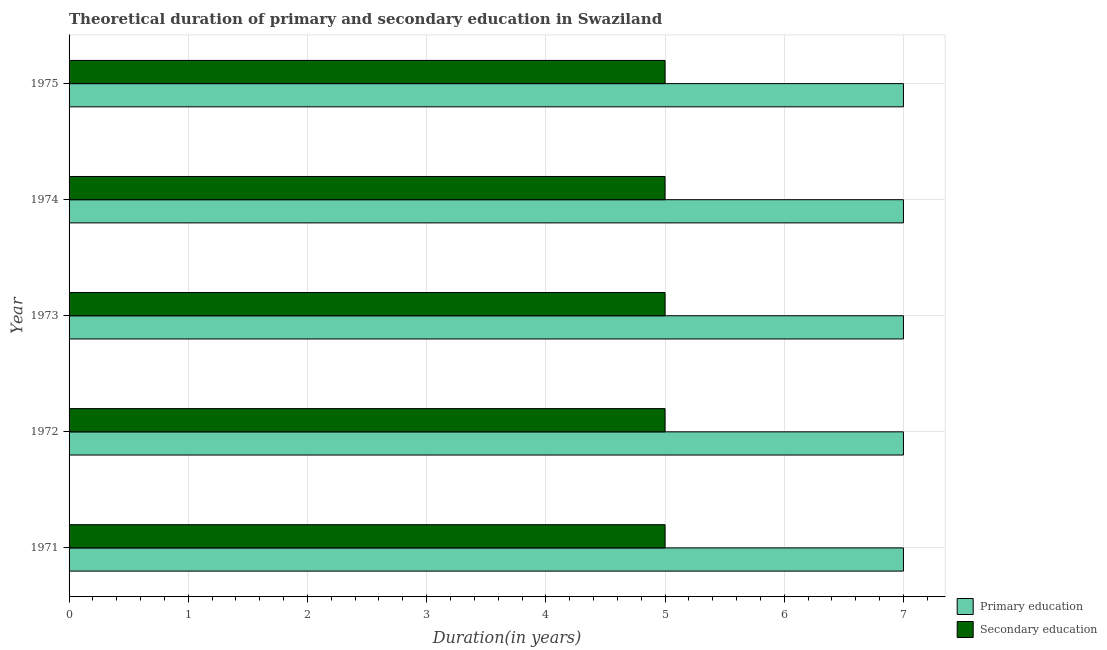How many bars are there on the 3rd tick from the bottom?
Make the answer very short. 2. What is the label of the 3rd group of bars from the top?
Your answer should be compact. 1973. What is the duration of secondary education in 1974?
Provide a succinct answer. 5. Across all years, what is the maximum duration of secondary education?
Keep it short and to the point. 5. Across all years, what is the minimum duration of primary education?
Offer a very short reply. 7. What is the total duration of primary education in the graph?
Provide a succinct answer. 35. What is the difference between the duration of secondary education in 1973 and the duration of primary education in 1974?
Provide a succinct answer. -2. In the year 1973, what is the difference between the duration of primary education and duration of secondary education?
Ensure brevity in your answer.  2. What is the ratio of the duration of secondary education in 1972 to that in 1975?
Offer a very short reply. 1. In how many years, is the duration of secondary education greater than the average duration of secondary education taken over all years?
Provide a short and direct response. 0. Is the sum of the duration of primary education in 1971 and 1972 greater than the maximum duration of secondary education across all years?
Provide a short and direct response. Yes. What does the 1st bar from the top in 1972 represents?
Your answer should be very brief. Secondary education. What does the 1st bar from the bottom in 1975 represents?
Make the answer very short. Primary education. How many bars are there?
Give a very brief answer. 10. What is the difference between two consecutive major ticks on the X-axis?
Your response must be concise. 1. Are the values on the major ticks of X-axis written in scientific E-notation?
Ensure brevity in your answer.  No. Where does the legend appear in the graph?
Ensure brevity in your answer.  Bottom right. How many legend labels are there?
Keep it short and to the point. 2. What is the title of the graph?
Make the answer very short. Theoretical duration of primary and secondary education in Swaziland. What is the label or title of the X-axis?
Provide a succinct answer. Duration(in years). What is the Duration(in years) in Primary education in 1971?
Provide a short and direct response. 7. What is the Duration(in years) of Primary education in 1972?
Ensure brevity in your answer.  7. What is the Duration(in years) in Secondary education in 1972?
Provide a succinct answer. 5. What is the Duration(in years) in Primary education in 1975?
Keep it short and to the point. 7. What is the Duration(in years) in Secondary education in 1975?
Offer a terse response. 5. What is the total Duration(in years) in Primary education in the graph?
Offer a terse response. 35. What is the difference between the Duration(in years) of Primary education in 1971 and that in 1972?
Ensure brevity in your answer.  0. What is the difference between the Duration(in years) in Secondary education in 1971 and that in 1972?
Your answer should be very brief. 0. What is the difference between the Duration(in years) in Primary education in 1971 and that in 1973?
Provide a short and direct response. 0. What is the difference between the Duration(in years) of Secondary education in 1971 and that in 1973?
Provide a short and direct response. 0. What is the difference between the Duration(in years) in Primary education in 1971 and that in 1974?
Offer a very short reply. 0. What is the difference between the Duration(in years) of Secondary education in 1971 and that in 1974?
Your answer should be very brief. 0. What is the difference between the Duration(in years) in Primary education in 1971 and that in 1975?
Your answer should be compact. 0. What is the difference between the Duration(in years) in Secondary education in 1971 and that in 1975?
Keep it short and to the point. 0. What is the difference between the Duration(in years) of Secondary education in 1972 and that in 1973?
Make the answer very short. 0. What is the difference between the Duration(in years) in Primary education in 1972 and that in 1974?
Ensure brevity in your answer.  0. What is the difference between the Duration(in years) in Secondary education in 1972 and that in 1974?
Provide a short and direct response. 0. What is the difference between the Duration(in years) of Primary education in 1972 and that in 1975?
Offer a very short reply. 0. What is the difference between the Duration(in years) of Secondary education in 1972 and that in 1975?
Provide a succinct answer. 0. What is the difference between the Duration(in years) in Primary education in 1973 and that in 1974?
Your response must be concise. 0. What is the difference between the Duration(in years) in Primary education in 1973 and that in 1975?
Your answer should be compact. 0. What is the difference between the Duration(in years) in Secondary education in 1974 and that in 1975?
Give a very brief answer. 0. What is the difference between the Duration(in years) of Primary education in 1971 and the Duration(in years) of Secondary education in 1972?
Keep it short and to the point. 2. What is the difference between the Duration(in years) in Primary education in 1971 and the Duration(in years) in Secondary education in 1973?
Provide a short and direct response. 2. What is the difference between the Duration(in years) of Primary education in 1972 and the Duration(in years) of Secondary education in 1973?
Offer a very short reply. 2. What is the difference between the Duration(in years) in Primary education in 1972 and the Duration(in years) in Secondary education in 1974?
Make the answer very short. 2. What is the difference between the Duration(in years) in Primary education in 1973 and the Duration(in years) in Secondary education in 1974?
Provide a succinct answer. 2. What is the average Duration(in years) in Secondary education per year?
Your response must be concise. 5. In the year 1971, what is the difference between the Duration(in years) of Primary education and Duration(in years) of Secondary education?
Offer a very short reply. 2. What is the ratio of the Duration(in years) in Secondary education in 1971 to that in 1972?
Keep it short and to the point. 1. What is the ratio of the Duration(in years) in Primary education in 1971 to that in 1973?
Make the answer very short. 1. What is the ratio of the Duration(in years) of Secondary education in 1971 to that in 1974?
Provide a succinct answer. 1. What is the ratio of the Duration(in years) in Secondary education in 1972 to that in 1973?
Give a very brief answer. 1. What is the ratio of the Duration(in years) in Primary education in 1972 to that in 1974?
Your response must be concise. 1. What is the ratio of the Duration(in years) in Primary education in 1972 to that in 1975?
Keep it short and to the point. 1. What is the ratio of the Duration(in years) of Primary education in 1973 to that in 1974?
Provide a succinct answer. 1. What is the difference between the highest and the lowest Duration(in years) in Primary education?
Your response must be concise. 0. 